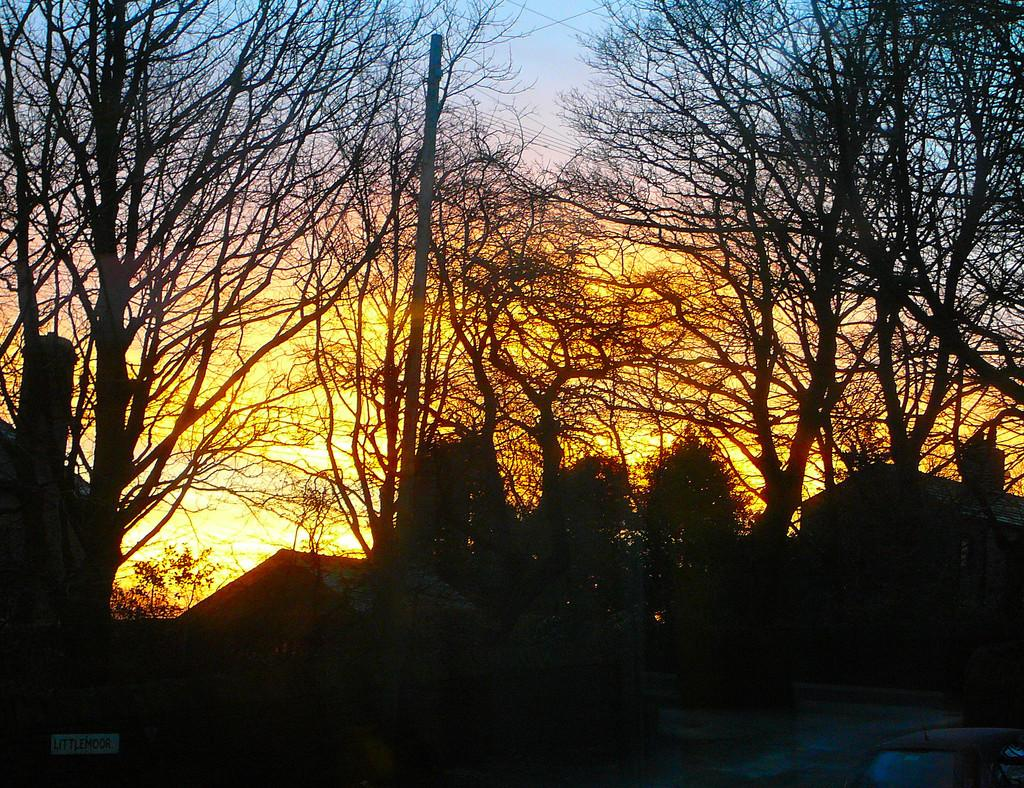What type of structures can be seen in the image? There are houses in the image. What other natural elements are present in the image? There are trees in the image. What can be observed in the background of the image? Sunlight is visible in the background of the image. What type of zinc is being used to construct the houses in the image? There is no mention of zinc being used in the construction of the houses in the image. Can you tell me where the nearest store is located in the image? There is no store visible in the image; it only features houses and trees. 